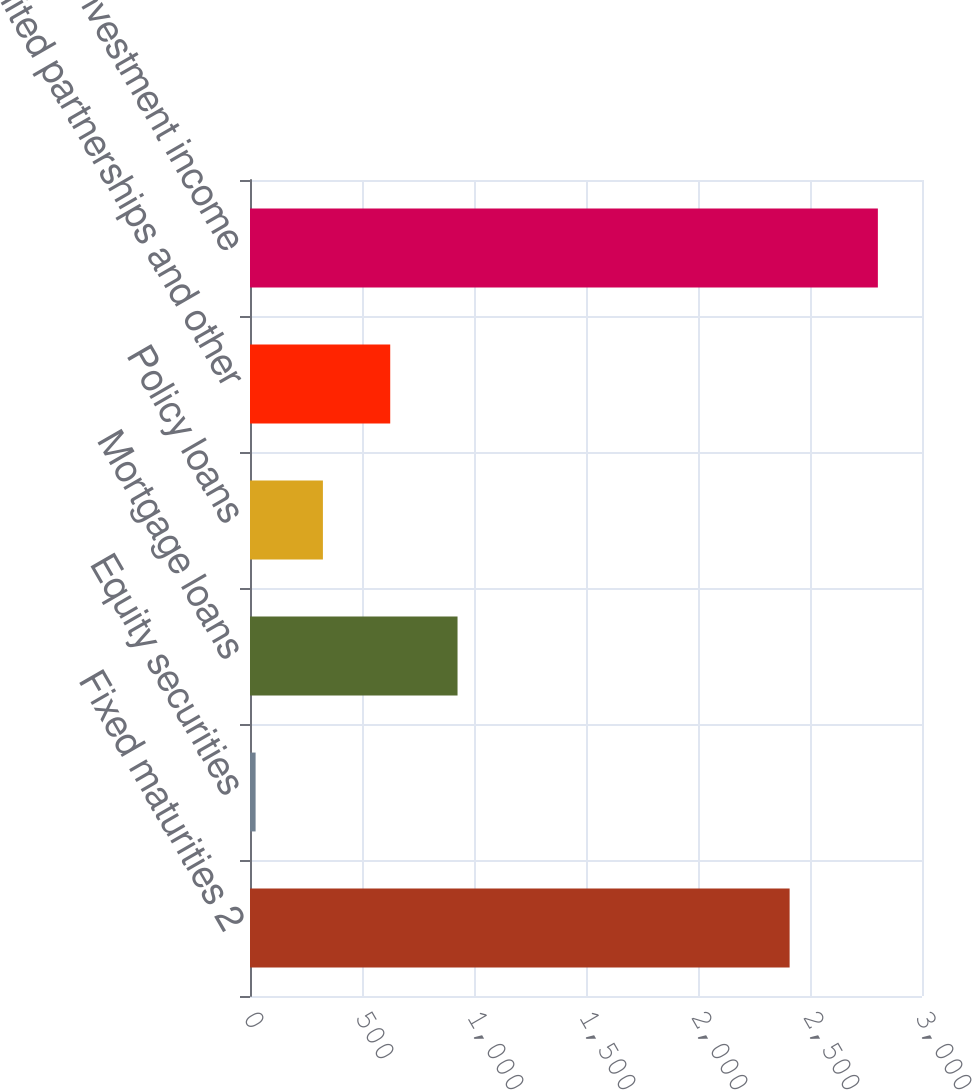<chart> <loc_0><loc_0><loc_500><loc_500><bar_chart><fcel>Fixed maturities 2<fcel>Equity securities<fcel>Mortgage loans<fcel>Policy loans<fcel>Limited partnerships and other<fcel>Total net investment income<nl><fcel>2409<fcel>25<fcel>926.5<fcel>325.5<fcel>626<fcel>2803<nl></chart> 